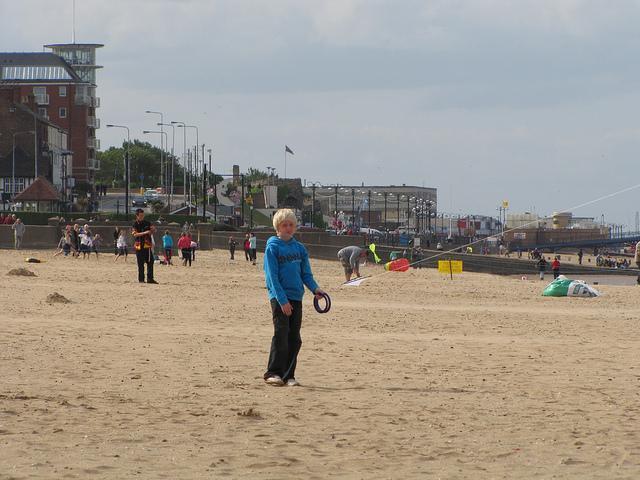How many bins are in there?
Give a very brief answer. 0. How many people are in the picture?
Give a very brief answer. 2. 